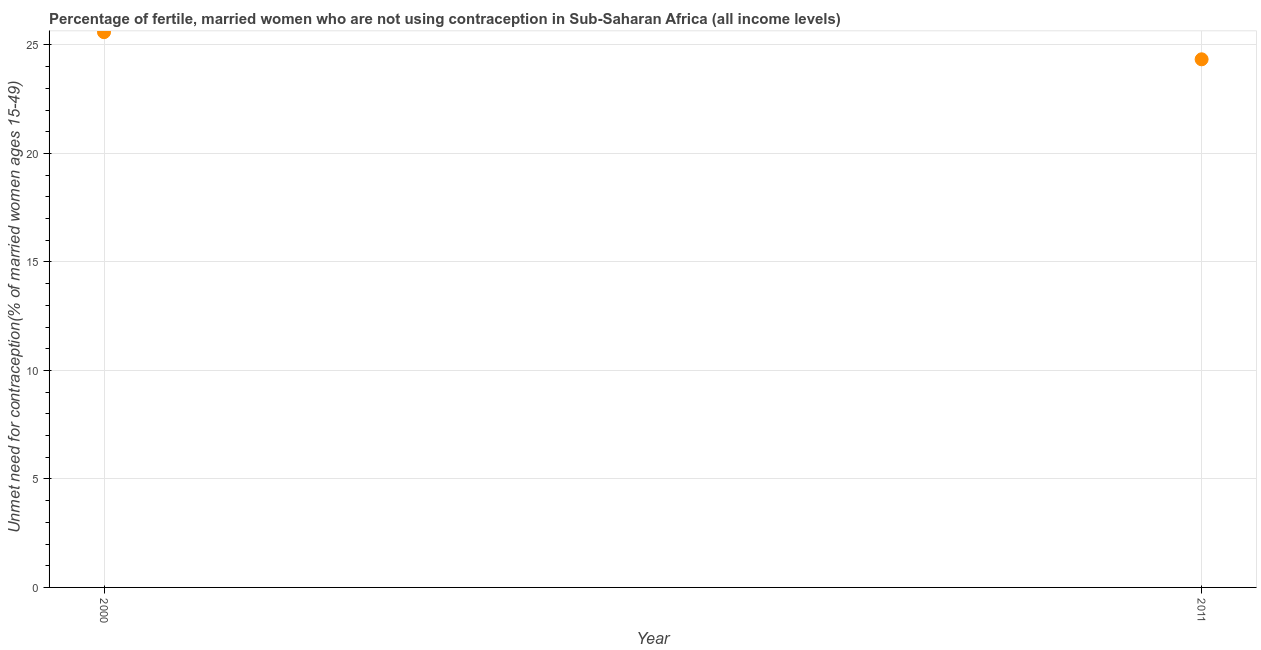What is the number of married women who are not using contraception in 2011?
Give a very brief answer. 24.34. Across all years, what is the maximum number of married women who are not using contraception?
Make the answer very short. 25.59. Across all years, what is the minimum number of married women who are not using contraception?
Your response must be concise. 24.34. In which year was the number of married women who are not using contraception maximum?
Ensure brevity in your answer.  2000. In which year was the number of married women who are not using contraception minimum?
Give a very brief answer. 2011. What is the sum of the number of married women who are not using contraception?
Provide a succinct answer. 49.93. What is the difference between the number of married women who are not using contraception in 2000 and 2011?
Your answer should be compact. 1.25. What is the average number of married women who are not using contraception per year?
Make the answer very short. 24.97. What is the median number of married women who are not using contraception?
Ensure brevity in your answer.  24.97. What is the ratio of the number of married women who are not using contraception in 2000 to that in 2011?
Keep it short and to the point. 1.05. How many dotlines are there?
Your answer should be very brief. 1. What is the difference between two consecutive major ticks on the Y-axis?
Provide a succinct answer. 5. What is the title of the graph?
Keep it short and to the point. Percentage of fertile, married women who are not using contraception in Sub-Saharan Africa (all income levels). What is the label or title of the X-axis?
Your answer should be compact. Year. What is the label or title of the Y-axis?
Give a very brief answer.  Unmet need for contraception(% of married women ages 15-49). What is the  Unmet need for contraception(% of married women ages 15-49) in 2000?
Make the answer very short. 25.59. What is the  Unmet need for contraception(% of married women ages 15-49) in 2011?
Provide a short and direct response. 24.34. What is the difference between the  Unmet need for contraception(% of married women ages 15-49) in 2000 and 2011?
Provide a succinct answer. 1.25. What is the ratio of the  Unmet need for contraception(% of married women ages 15-49) in 2000 to that in 2011?
Ensure brevity in your answer.  1.05. 